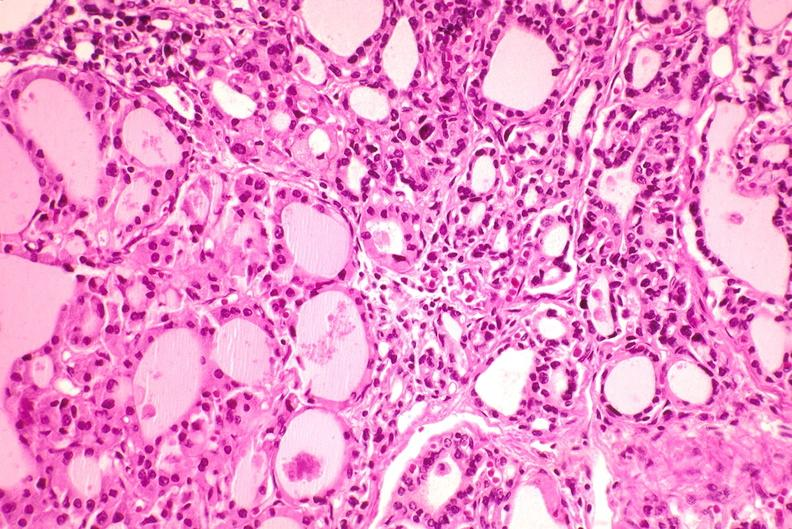does this image show thyroid, hashimoto 's?
Answer the question using a single word or phrase. Yes 